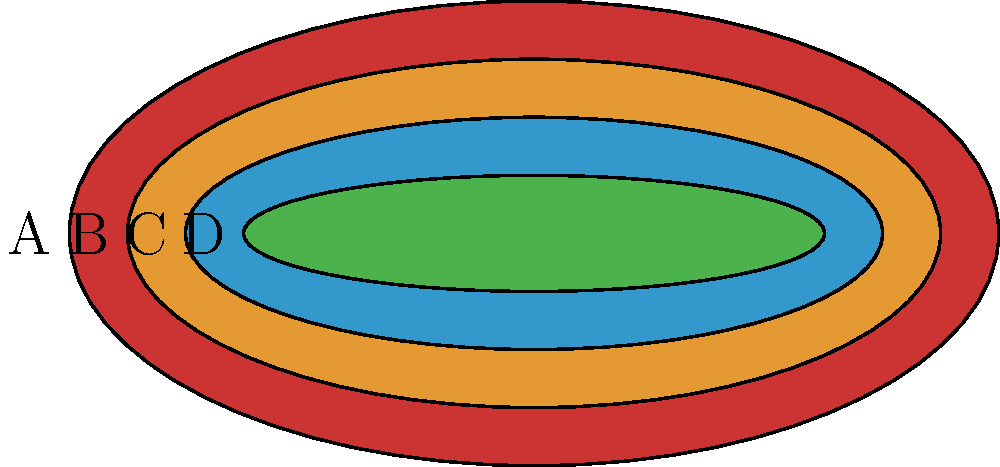Analyze the color palette and patterns depicted in the image, which represents a traditional textile from a specific culture. How would you incorporate these elements into an interior space to create a cohesive cultural design, and what considerations should be made regarding the symbolism and cultural significance of the colors and patterns? To incorporate the elements from this traditional textile into an interior space while creating a cohesive cultural design, follow these steps:

1. Color Analysis:
   A. Identify the main colors: red (A), orange (B), blue (C), and green (D).
   B. Note the progression from warm to cool colors.

2. Pattern Analysis:
   A. Observe the concentric oval shapes.
   B. Notice the decreasing size of the ovals from outer to inner.

3. Cultural Significance:
   A. Research the specific culture associated with this textile.
   B. Understand the symbolism of each color and pattern in that culture.

4. Interior Application:
   A. Use the color palette as a guide for selecting paint, fabrics, and accessories.
   B. Incorporate the concentric oval pattern in various design elements (e.g., rugs, wall art, textiles).

5. Balance and Harmony:
   A. Use the dominant color (red) as an accent color in the space.
   B. Utilize the secondary colors (orange, blue, green) for larger surfaces and furnishings.
   C. Maintain the warm-to-cool color progression in the room layout.

6. Cultural Elements:
   A. Introduce traditional artifacts or artwork that complement the textile's design.
   B. Use materials commonly found in the culture's traditional interiors.

7. Modern Integration:
   A. Blend traditional elements with contemporary furniture and fixtures.
   B. Use the concentric oval pattern in modern interpretations (e.g., abstract art, custom furniture design).

8. Lighting:
   A. Choose lighting that enhances the chosen color palette.
   B. Consider natural light sources and their effect on the colors throughout the day.

9. Texture:
   A. Incorporate textures that reflect the textile's cultural origins.
   B. Use a mix of smooth and textured surfaces to add depth to the design.

10. Respect and Authenticity:
    A. Ensure the design respects the cultural significance of the patterns and colors.
    B. Avoid cultural appropriation by understanding and honoring the textile's origins.

By following these steps, you can create an interior space that effectively incorporates the cultural elements of the textile while maintaining a cohesive and respectful design.
Answer: Incorporate warm-to-cool color progression and concentric oval patterns in paint, fabrics, and decor. Balance traditional elements with modern design, respecting cultural symbolism and significance. 